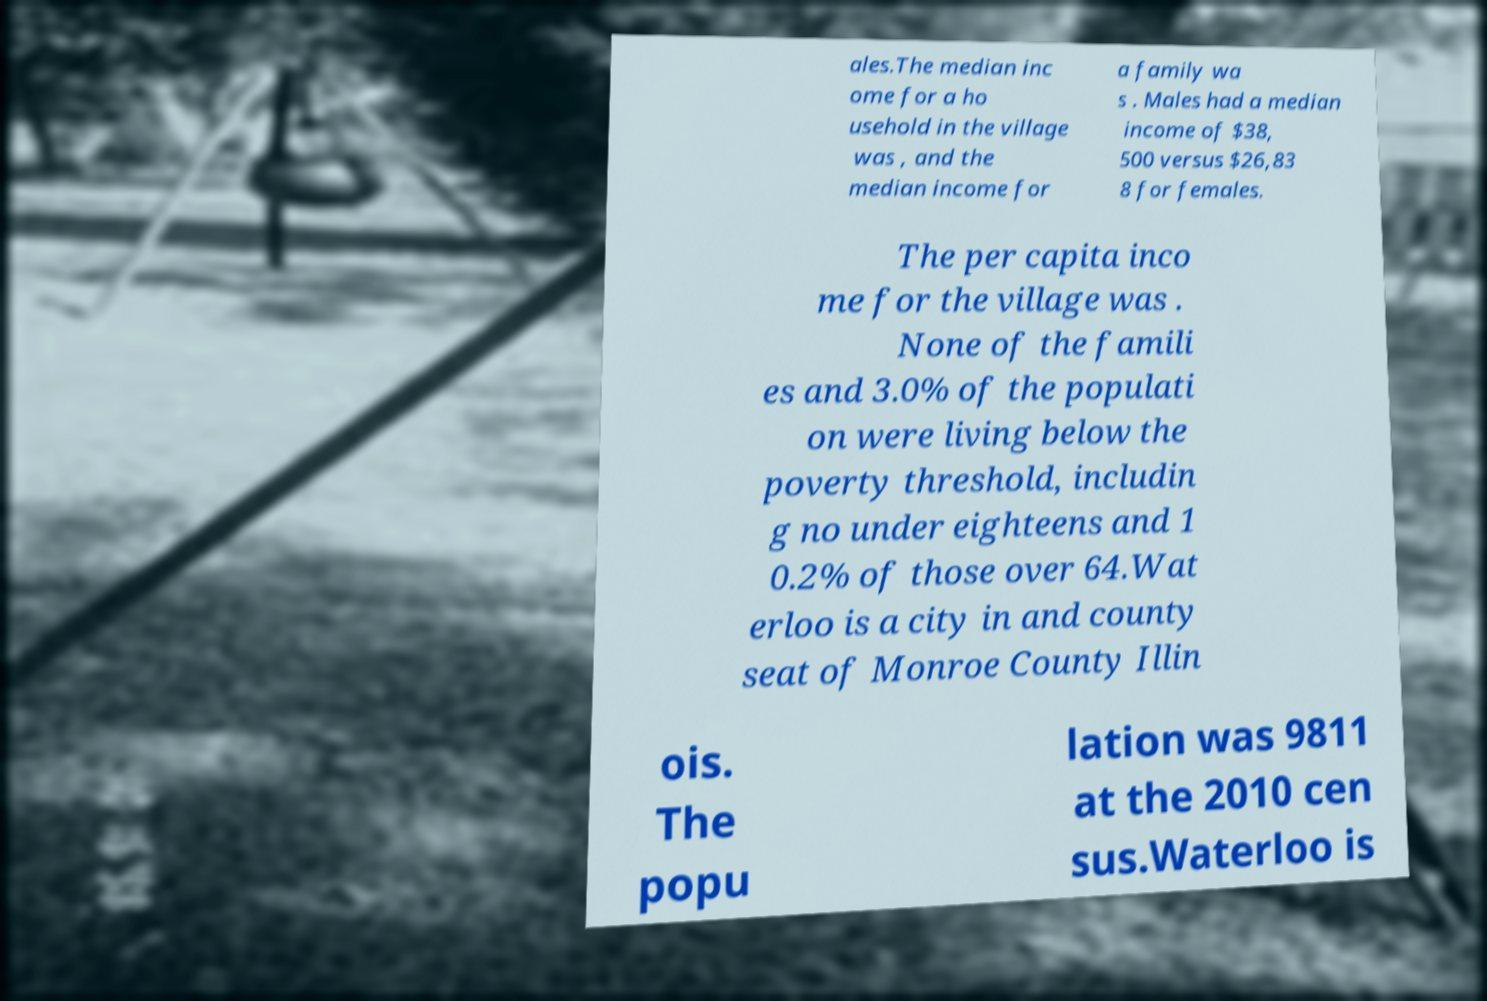Can you accurately transcribe the text from the provided image for me? ales.The median inc ome for a ho usehold in the village was , and the median income for a family wa s . Males had a median income of $38, 500 versus $26,83 8 for females. The per capita inco me for the village was . None of the famili es and 3.0% of the populati on were living below the poverty threshold, includin g no under eighteens and 1 0.2% of those over 64.Wat erloo is a city in and county seat of Monroe County Illin ois. The popu lation was 9811 at the 2010 cen sus.Waterloo is 